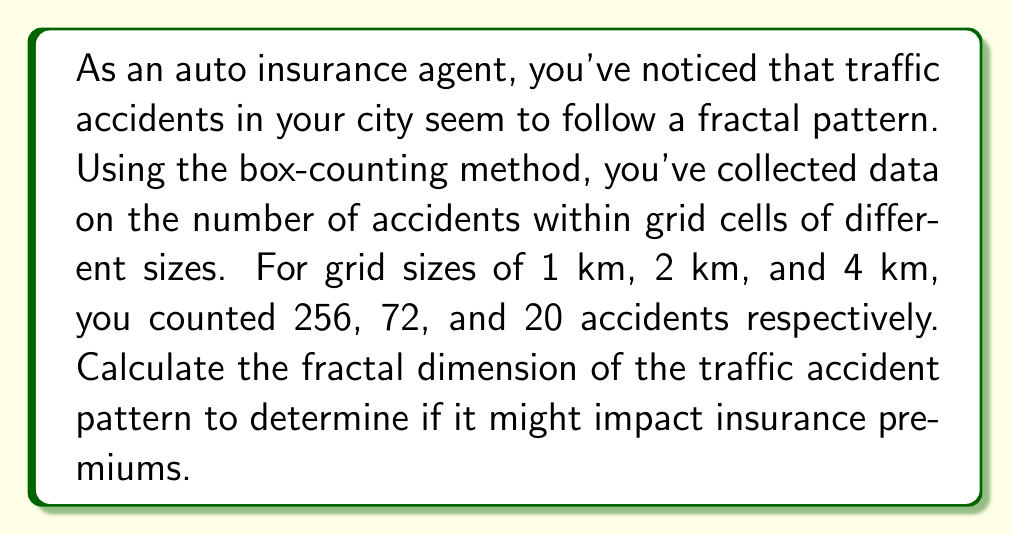Could you help me with this problem? To calculate the fractal dimension using the box-counting method, we'll follow these steps:

1) The box-counting dimension is given by the formula:

   $$D = \lim_{\epsilon \to 0} \frac{\log N(\epsilon)}{\log(1/\epsilon)}$$

   where $N(\epsilon)$ is the number of boxes of size $\epsilon$ needed to cover the set.

2) We can approximate this using the slope of the log-log plot of $N(\epsilon)$ vs. $1/\epsilon$.

3) Let's organize our data:
   $\epsilon$ (km) | $1/\epsilon$ | $N(\epsilon)$
   1               | 1            | 256
   2               | 0.5          | 72
   4               | 0.25         | 20

4) Now, we'll calculate $\log(1/\epsilon)$ and $\log N(\epsilon)$:
   $\log(1/\epsilon)$ | $\log N(\epsilon)$
   0                  | $\log 256 \approx 5.545$
   $-\log 2 \approx -0.693$ | $\log 72 \approx 4.277$
   $-\log 4 \approx -1.386$ | $\log 20 \approx 2.996$

5) The fractal dimension is the negative of the slope of this line. We can use the first and last points to calculate it:

   $$D = -\frac{\log N(\epsilon_2) - \log N(\epsilon_1)}{\log(1/\epsilon_2) - \log(1/\epsilon_1)}$$

6) Plugging in our values:

   $$D = -\frac{2.996 - 5.545}{-1.386 - 0} \approx 1.837$$

This fractal dimension suggests a complex pattern of accidents that might indeed impact insurance premiums.
Answer: $D \approx 1.837$ 